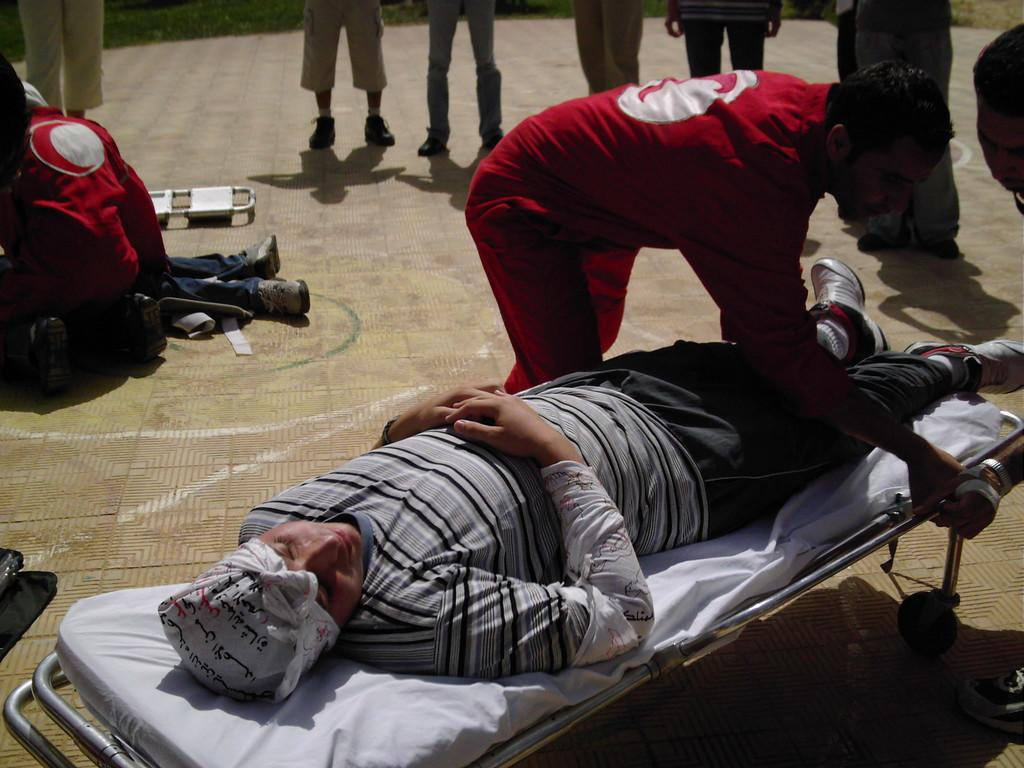What is the main subject of the image? There is a person lying on a stretcher in the image. Can you describe the person standing in the image? The standing person is wearing a red dress. Are there any other people visible in the image? Yes, there are other people visible in the background of the image. What type of rhythm is the lawyer playing on the cellar in the image? There is no lawyer, cellar, or rhythm present in the image. 